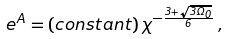Convert formula to latex. <formula><loc_0><loc_0><loc_500><loc_500>e ^ { A } = ( c o n s t a n t ) \, \chi ^ { - \frac { 3 + \sqrt { 3 \Omega _ { 0 } } } { 6 } } \, ,</formula> 